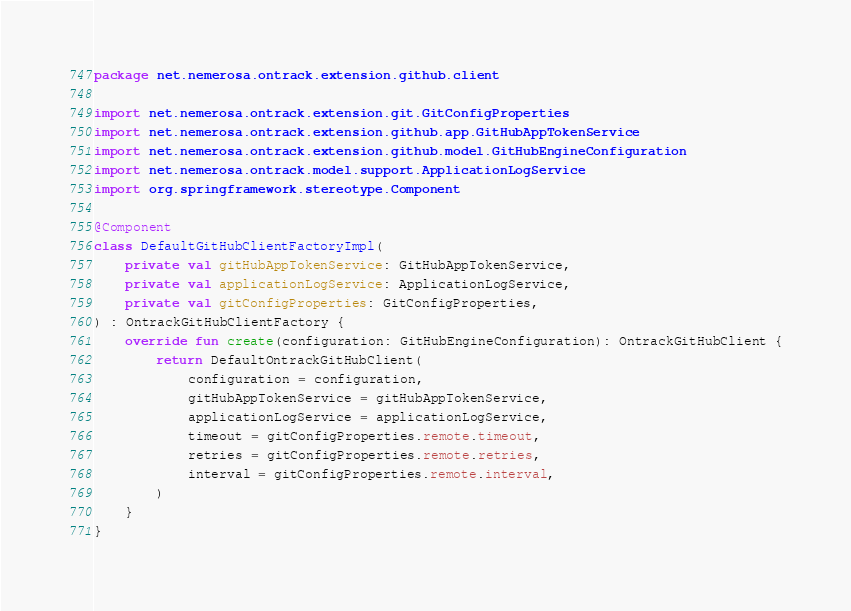Convert code to text. <code><loc_0><loc_0><loc_500><loc_500><_Kotlin_>package net.nemerosa.ontrack.extension.github.client

import net.nemerosa.ontrack.extension.git.GitConfigProperties
import net.nemerosa.ontrack.extension.github.app.GitHubAppTokenService
import net.nemerosa.ontrack.extension.github.model.GitHubEngineConfiguration
import net.nemerosa.ontrack.model.support.ApplicationLogService
import org.springframework.stereotype.Component

@Component
class DefaultGitHubClientFactoryImpl(
    private val gitHubAppTokenService: GitHubAppTokenService,
    private val applicationLogService: ApplicationLogService,
    private val gitConfigProperties: GitConfigProperties,
) : OntrackGitHubClientFactory {
    override fun create(configuration: GitHubEngineConfiguration): OntrackGitHubClient {
        return DefaultOntrackGitHubClient(
            configuration = configuration,
            gitHubAppTokenService = gitHubAppTokenService,
            applicationLogService = applicationLogService,
            timeout = gitConfigProperties.remote.timeout,
            retries = gitConfigProperties.remote.retries,
            interval = gitConfigProperties.remote.interval,
        )
    }
}</code> 